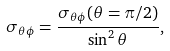<formula> <loc_0><loc_0><loc_500><loc_500>\sigma _ { \theta \phi } = \frac { \sigma _ { \theta \phi } ( \theta = \pi / 2 ) } { \sin ^ { 2 } \theta } ,</formula> 